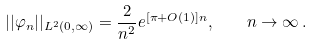<formula> <loc_0><loc_0><loc_500><loc_500>| | \varphi _ { n } | | _ { L ^ { 2 } ( 0 , \infty ) } = \frac { 2 } { n ^ { 2 } } e ^ { [ \pi + O ( 1 ) ] n } , \quad n \to \infty \, .</formula> 